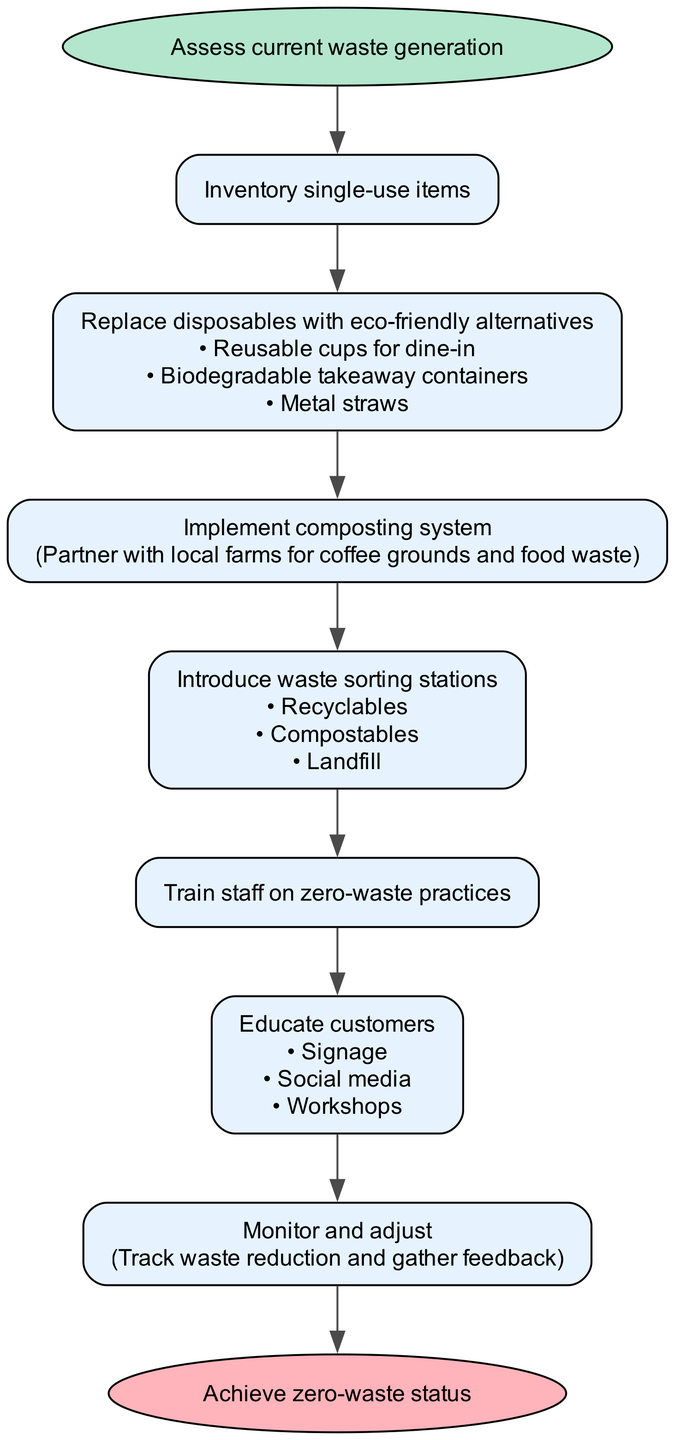What is the first step in the process? The first step is clearly labeled in the diagram as "Assess current waste generation." It is the starting point that directs the flow to the next steps in the process.
Answer: Assess current waste generation How many options are provided for replacing disposables? The step "Replace disposables with eco-friendly alternatives" has three options listed beneath it: "Reusable cups for dine-in," "Biodegradable takeaway containers," and "Metal straws." By counting these options, we find there are three.
Answer: 3 What comes after the composting system implementation? After the step labeled "Implement composting system," which includes details about partnering with local farms, the next step indicated in the flow is "Introduce waste sorting stations." This gives a clear sense of progression from one action to the next.
Answer: Introduce waste sorting stations Which step involves tracking waste reduction? The step "Monitor and adjust" is the one that specifically involves tracking waste reduction. It also mentions gathering feedback, which is part of the monitoring process. This directs the flow of information on how effective the previous steps have been.
Answer: Monitor and adjust What are the options in the step for educating customers? In the step labeled "Educate customers," three specific options are provided: "Signage," "Social media," and "Workshops." This indicates different methods that can be utilized to enhance customer education on zero-waste practices.
Answer: Signage, Social media, Workshops What is the final outcome of the flow chart? The flow chart concludes with the end node labeled "Achieve zero-waste status," indicating the ultimate goal of the processes laid out in the diagram and the success expected from following the steps.
Answer: Achieve zero-waste status What is the purpose of waste sorting stations? The purpose of "Introduce waste sorting stations" can be deduced as a means to categorize waste effectively, as highlighted by the options given: "Recyclables," "Compostables," and "Landfill." This helps in correctly managing waste disposal to achieve a zero-waste goal.
Answer: Categorize waste What is detailed in the implementation step of composting? The step "Implement composting system" includes the specific detail of partnering with local farms for coffee grounds and food waste, indicating a practical approach to managing organic waste effectively as part of the zero-waste initiative.
Answer: Partner with local farms for coffee grounds and food waste 